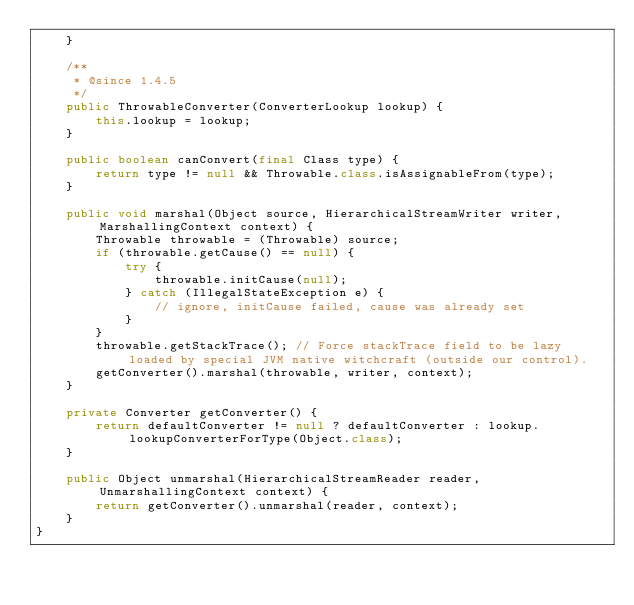Convert code to text. <code><loc_0><loc_0><loc_500><loc_500><_Java_>    }

    /**
     * @since 1.4.5
     */
    public ThrowableConverter(ConverterLookup lookup) {
        this.lookup = lookup;
    }

    public boolean canConvert(final Class type) {
        return type != null && Throwable.class.isAssignableFrom(type);
    }

    public void marshal(Object source, HierarchicalStreamWriter writer, MarshallingContext context) {
        Throwable throwable = (Throwable) source;
        if (throwable.getCause() == null) {
            try {
                throwable.initCause(null);
            } catch (IllegalStateException e) {
                // ignore, initCause failed, cause was already set
            }
        }
        throwable.getStackTrace(); // Force stackTrace field to be lazy loaded by special JVM native witchcraft (outside our control).
        getConverter().marshal(throwable, writer, context);
    }

    private Converter getConverter() {
        return defaultConverter != null ? defaultConverter : lookup.lookupConverterForType(Object.class);
    }

    public Object unmarshal(HierarchicalStreamReader reader, UnmarshallingContext context) {
        return getConverter().unmarshal(reader, context);
    }
}
</code> 